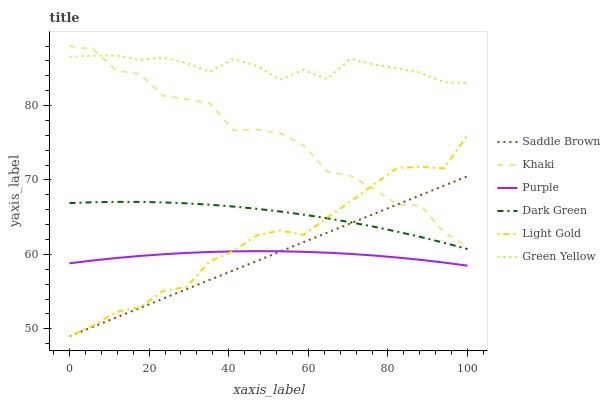Does Saddle Brown have the minimum area under the curve?
Answer yes or no. Yes. Does Green Yellow have the maximum area under the curve?
Answer yes or no. Yes. Does Purple have the minimum area under the curve?
Answer yes or no. No. Does Purple have the maximum area under the curve?
Answer yes or no. No. Is Saddle Brown the smoothest?
Answer yes or no. Yes. Is Khaki the roughest?
Answer yes or no. Yes. Is Purple the smoothest?
Answer yes or no. No. Is Purple the roughest?
Answer yes or no. No. Does Purple have the lowest value?
Answer yes or no. No. Does Khaki have the highest value?
Answer yes or no. Yes. Does Green Yellow have the highest value?
Answer yes or no. No. Is Light Gold less than Green Yellow?
Answer yes or no. Yes. Is Dark Green greater than Purple?
Answer yes or no. Yes. Does Light Gold intersect Green Yellow?
Answer yes or no. No. 